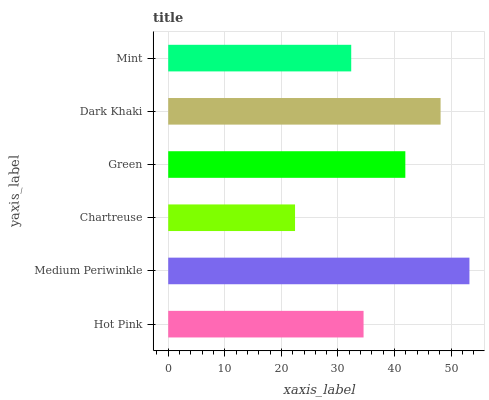Is Chartreuse the minimum?
Answer yes or no. Yes. Is Medium Periwinkle the maximum?
Answer yes or no. Yes. Is Medium Periwinkle the minimum?
Answer yes or no. No. Is Chartreuse the maximum?
Answer yes or no. No. Is Medium Periwinkle greater than Chartreuse?
Answer yes or no. Yes. Is Chartreuse less than Medium Periwinkle?
Answer yes or no. Yes. Is Chartreuse greater than Medium Periwinkle?
Answer yes or no. No. Is Medium Periwinkle less than Chartreuse?
Answer yes or no. No. Is Green the high median?
Answer yes or no. Yes. Is Hot Pink the low median?
Answer yes or no. Yes. Is Dark Khaki the high median?
Answer yes or no. No. Is Dark Khaki the low median?
Answer yes or no. No. 